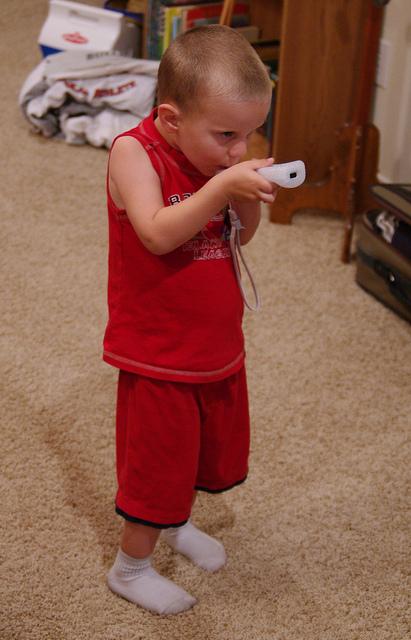What game console is the little boy playing?
Give a very brief answer. Wii. What animal is on the boys shorts?
Give a very brief answer. None. What is this kid holding?
Short answer required. Wii remote. How many game controllers are shown in the picture?
Concise answer only. 1. Is it safe for the child to be standing there?
Be succinct. Yes. Where are his shoes?
Write a very short answer. Gone. Is the child all dressed in red?
Quick response, please. Yes. 